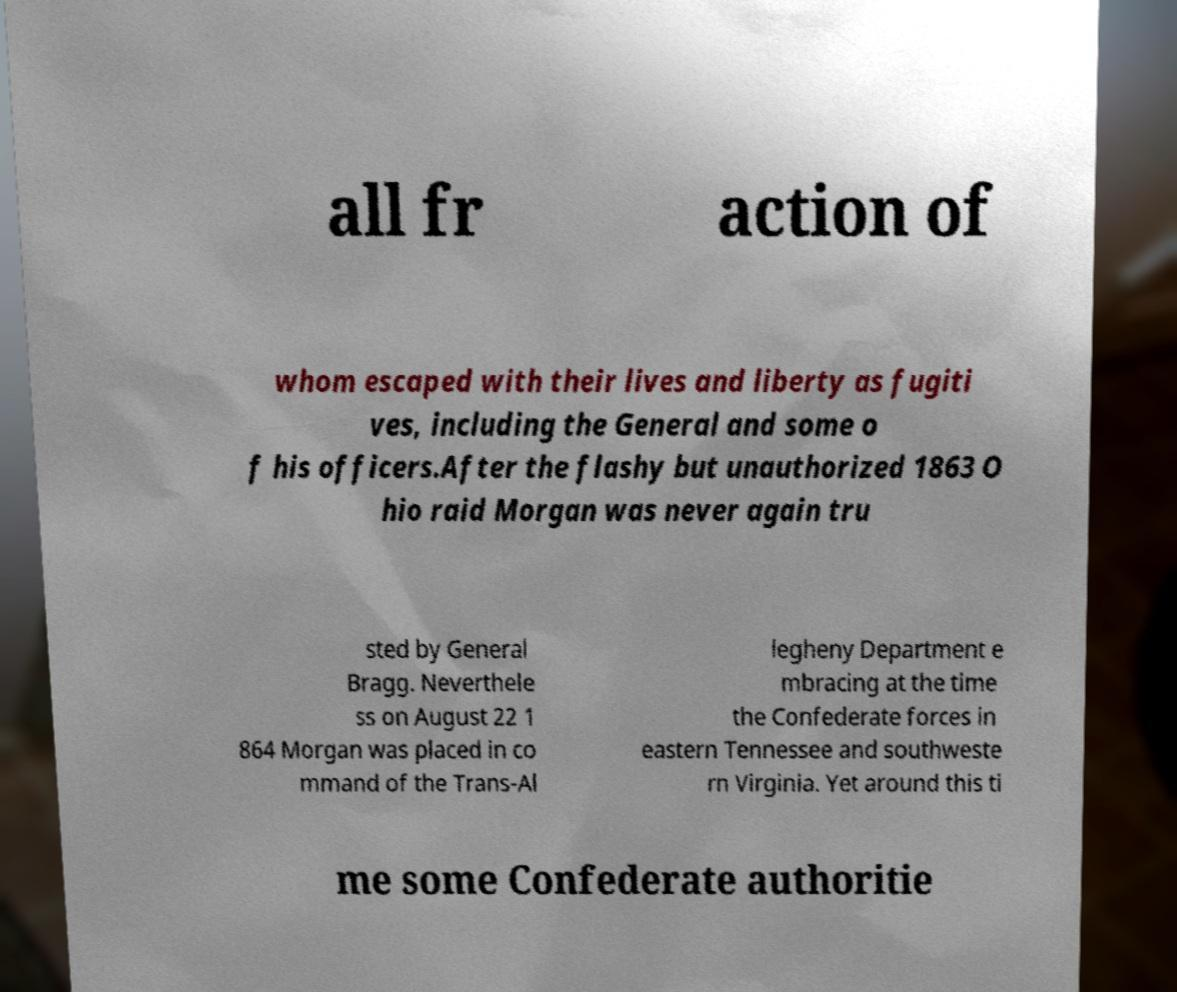Can you read and provide the text displayed in the image?This photo seems to have some interesting text. Can you extract and type it out for me? all fr action of whom escaped with their lives and liberty as fugiti ves, including the General and some o f his officers.After the flashy but unauthorized 1863 O hio raid Morgan was never again tru sted by General Bragg. Neverthele ss on August 22 1 864 Morgan was placed in co mmand of the Trans-Al legheny Department e mbracing at the time the Confederate forces in eastern Tennessee and southweste rn Virginia. Yet around this ti me some Confederate authoritie 